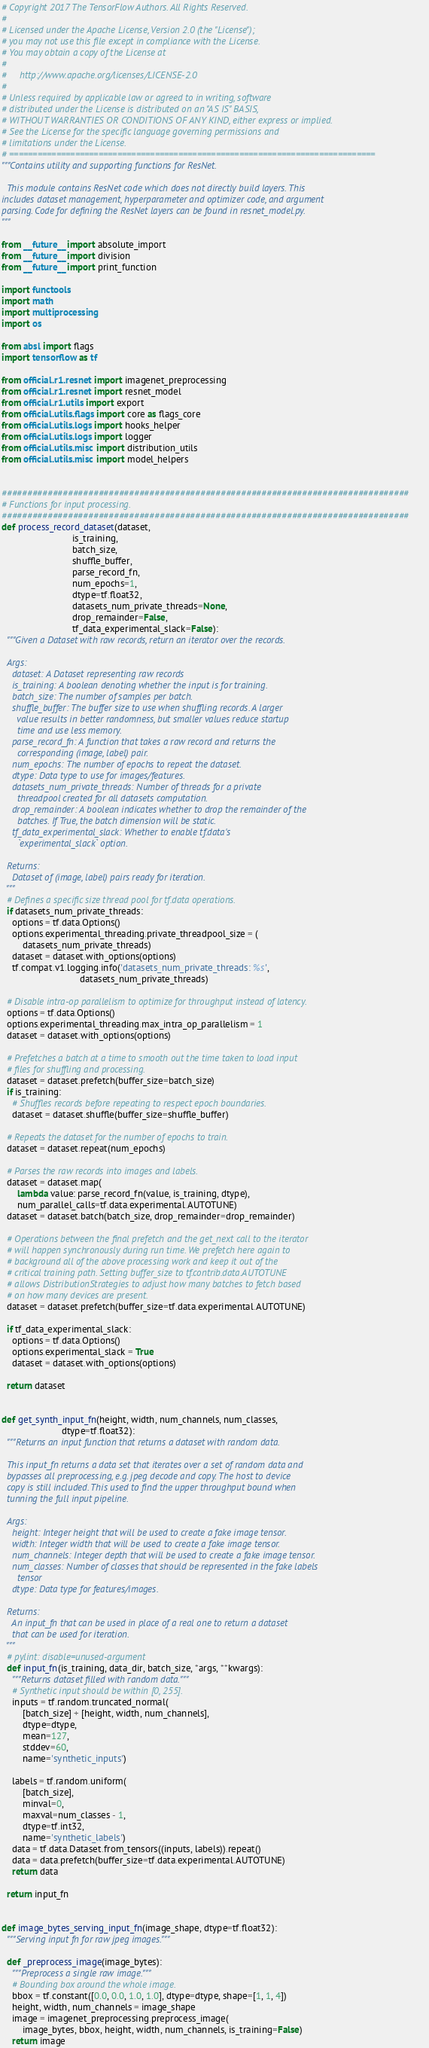<code> <loc_0><loc_0><loc_500><loc_500><_Python_># Copyright 2017 The TensorFlow Authors. All Rights Reserved.
#
# Licensed under the Apache License, Version 2.0 (the "License");
# you may not use this file except in compliance with the License.
# You may obtain a copy of the License at
#
#     http://www.apache.org/licenses/LICENSE-2.0
#
# Unless required by applicable law or agreed to in writing, software
# distributed under the License is distributed on an "AS IS" BASIS,
# WITHOUT WARRANTIES OR CONDITIONS OF ANY KIND, either express or implied.
# See the License for the specific language governing permissions and
# limitations under the License.
# ==============================================================================
"""Contains utility and supporting functions for ResNet.

  This module contains ResNet code which does not directly build layers. This
includes dataset management, hyperparameter and optimizer code, and argument
parsing. Code for defining the ResNet layers can be found in resnet_model.py.
"""

from __future__ import absolute_import
from __future__ import division
from __future__ import print_function

import functools
import math
import multiprocessing
import os

from absl import flags
import tensorflow as tf

from official.r1.resnet import imagenet_preprocessing
from official.r1.resnet import resnet_model
from official.r1.utils import export
from official.utils.flags import core as flags_core
from official.utils.logs import hooks_helper
from official.utils.logs import logger
from official.utils.misc import distribution_utils
from official.utils.misc import model_helpers


################################################################################
# Functions for input processing.
################################################################################
def process_record_dataset(dataset,
                           is_training,
                           batch_size,
                           shuffle_buffer,
                           parse_record_fn,
                           num_epochs=1,
                           dtype=tf.float32,
                           datasets_num_private_threads=None,
                           drop_remainder=False,
                           tf_data_experimental_slack=False):
  """Given a Dataset with raw records, return an iterator over the records.

  Args:
    dataset: A Dataset representing raw records
    is_training: A boolean denoting whether the input is for training.
    batch_size: The number of samples per batch.
    shuffle_buffer: The buffer size to use when shuffling records. A larger
      value results in better randomness, but smaller values reduce startup
      time and use less memory.
    parse_record_fn: A function that takes a raw record and returns the
      corresponding (image, label) pair.
    num_epochs: The number of epochs to repeat the dataset.
    dtype: Data type to use for images/features.
    datasets_num_private_threads: Number of threads for a private
      threadpool created for all datasets computation.
    drop_remainder: A boolean indicates whether to drop the remainder of the
      batches. If True, the batch dimension will be static.
    tf_data_experimental_slack: Whether to enable tf.data's
      `experimental_slack` option.

  Returns:
    Dataset of (image, label) pairs ready for iteration.
  """
  # Defines a specific size thread pool for tf.data operations.
  if datasets_num_private_threads:
    options = tf.data.Options()
    options.experimental_threading.private_threadpool_size = (
        datasets_num_private_threads)
    dataset = dataset.with_options(options)
    tf.compat.v1.logging.info('datasets_num_private_threads: %s',
                              datasets_num_private_threads)

  # Disable intra-op parallelism to optimize for throughput instead of latency.
  options = tf.data.Options()
  options.experimental_threading.max_intra_op_parallelism = 1
  dataset = dataset.with_options(options)

  # Prefetches a batch at a time to smooth out the time taken to load input
  # files for shuffling and processing.
  dataset = dataset.prefetch(buffer_size=batch_size)
  if is_training:
    # Shuffles records before repeating to respect epoch boundaries.
    dataset = dataset.shuffle(buffer_size=shuffle_buffer)

  # Repeats the dataset for the number of epochs to train.
  dataset = dataset.repeat(num_epochs)

  # Parses the raw records into images and labels.
  dataset = dataset.map(
      lambda value: parse_record_fn(value, is_training, dtype),
      num_parallel_calls=tf.data.experimental.AUTOTUNE)
  dataset = dataset.batch(batch_size, drop_remainder=drop_remainder)

  # Operations between the final prefetch and the get_next call to the iterator
  # will happen synchronously during run time. We prefetch here again to
  # background all of the above processing work and keep it out of the
  # critical training path. Setting buffer_size to tf.contrib.data.AUTOTUNE
  # allows DistributionStrategies to adjust how many batches to fetch based
  # on how many devices are present.
  dataset = dataset.prefetch(buffer_size=tf.data.experimental.AUTOTUNE)

  if tf_data_experimental_slack:
    options = tf.data.Options()
    options.experimental_slack = True
    dataset = dataset.with_options(options)

  return dataset


def get_synth_input_fn(height, width, num_channels, num_classes,
                       dtype=tf.float32):
  """Returns an input function that returns a dataset with random data.

  This input_fn returns a data set that iterates over a set of random data and
  bypasses all preprocessing, e.g. jpeg decode and copy. The host to device
  copy is still included. This used to find the upper throughput bound when
  tunning the full input pipeline.

  Args:
    height: Integer height that will be used to create a fake image tensor.
    width: Integer width that will be used to create a fake image tensor.
    num_channels: Integer depth that will be used to create a fake image tensor.
    num_classes: Number of classes that should be represented in the fake labels
      tensor
    dtype: Data type for features/images.

  Returns:
    An input_fn that can be used in place of a real one to return a dataset
    that can be used for iteration.
  """
  # pylint: disable=unused-argument
  def input_fn(is_training, data_dir, batch_size, *args, **kwargs):
    """Returns dataset filled with random data."""
    # Synthetic input should be within [0, 255].
    inputs = tf.random.truncated_normal(
        [batch_size] + [height, width, num_channels],
        dtype=dtype,
        mean=127,
        stddev=60,
        name='synthetic_inputs')

    labels = tf.random.uniform(
        [batch_size],
        minval=0,
        maxval=num_classes - 1,
        dtype=tf.int32,
        name='synthetic_labels')
    data = tf.data.Dataset.from_tensors((inputs, labels)).repeat()
    data = data.prefetch(buffer_size=tf.data.experimental.AUTOTUNE)
    return data

  return input_fn


def image_bytes_serving_input_fn(image_shape, dtype=tf.float32):
  """Serving input fn for raw jpeg images."""

  def _preprocess_image(image_bytes):
    """Preprocess a single raw image."""
    # Bounding box around the whole image.
    bbox = tf.constant([0.0, 0.0, 1.0, 1.0], dtype=dtype, shape=[1, 1, 4])
    height, width, num_channels = image_shape
    image = imagenet_preprocessing.preprocess_image(
        image_bytes, bbox, height, width, num_channels, is_training=False)
    return image
</code> 